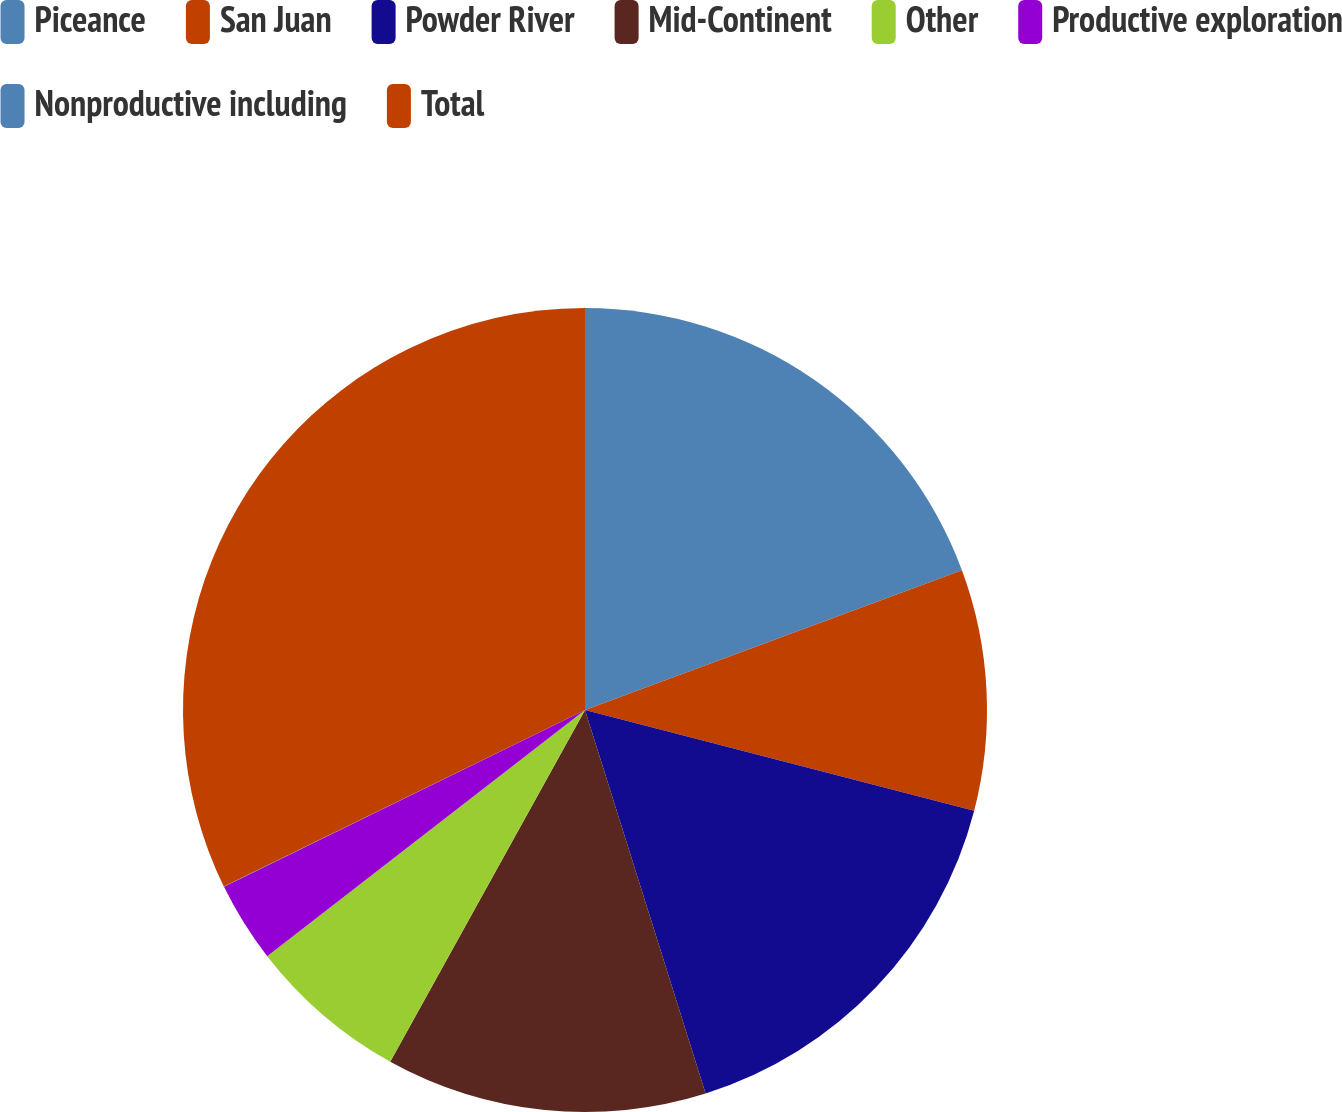<chart> <loc_0><loc_0><loc_500><loc_500><pie_chart><fcel>Piceance<fcel>San Juan<fcel>Powder River<fcel>Mid-Continent<fcel>Other<fcel>Productive exploration<fcel>Nonproductive including<fcel>Total<nl><fcel>19.35%<fcel>9.68%<fcel>16.12%<fcel>12.9%<fcel>6.46%<fcel>3.24%<fcel>0.02%<fcel>32.23%<nl></chart> 